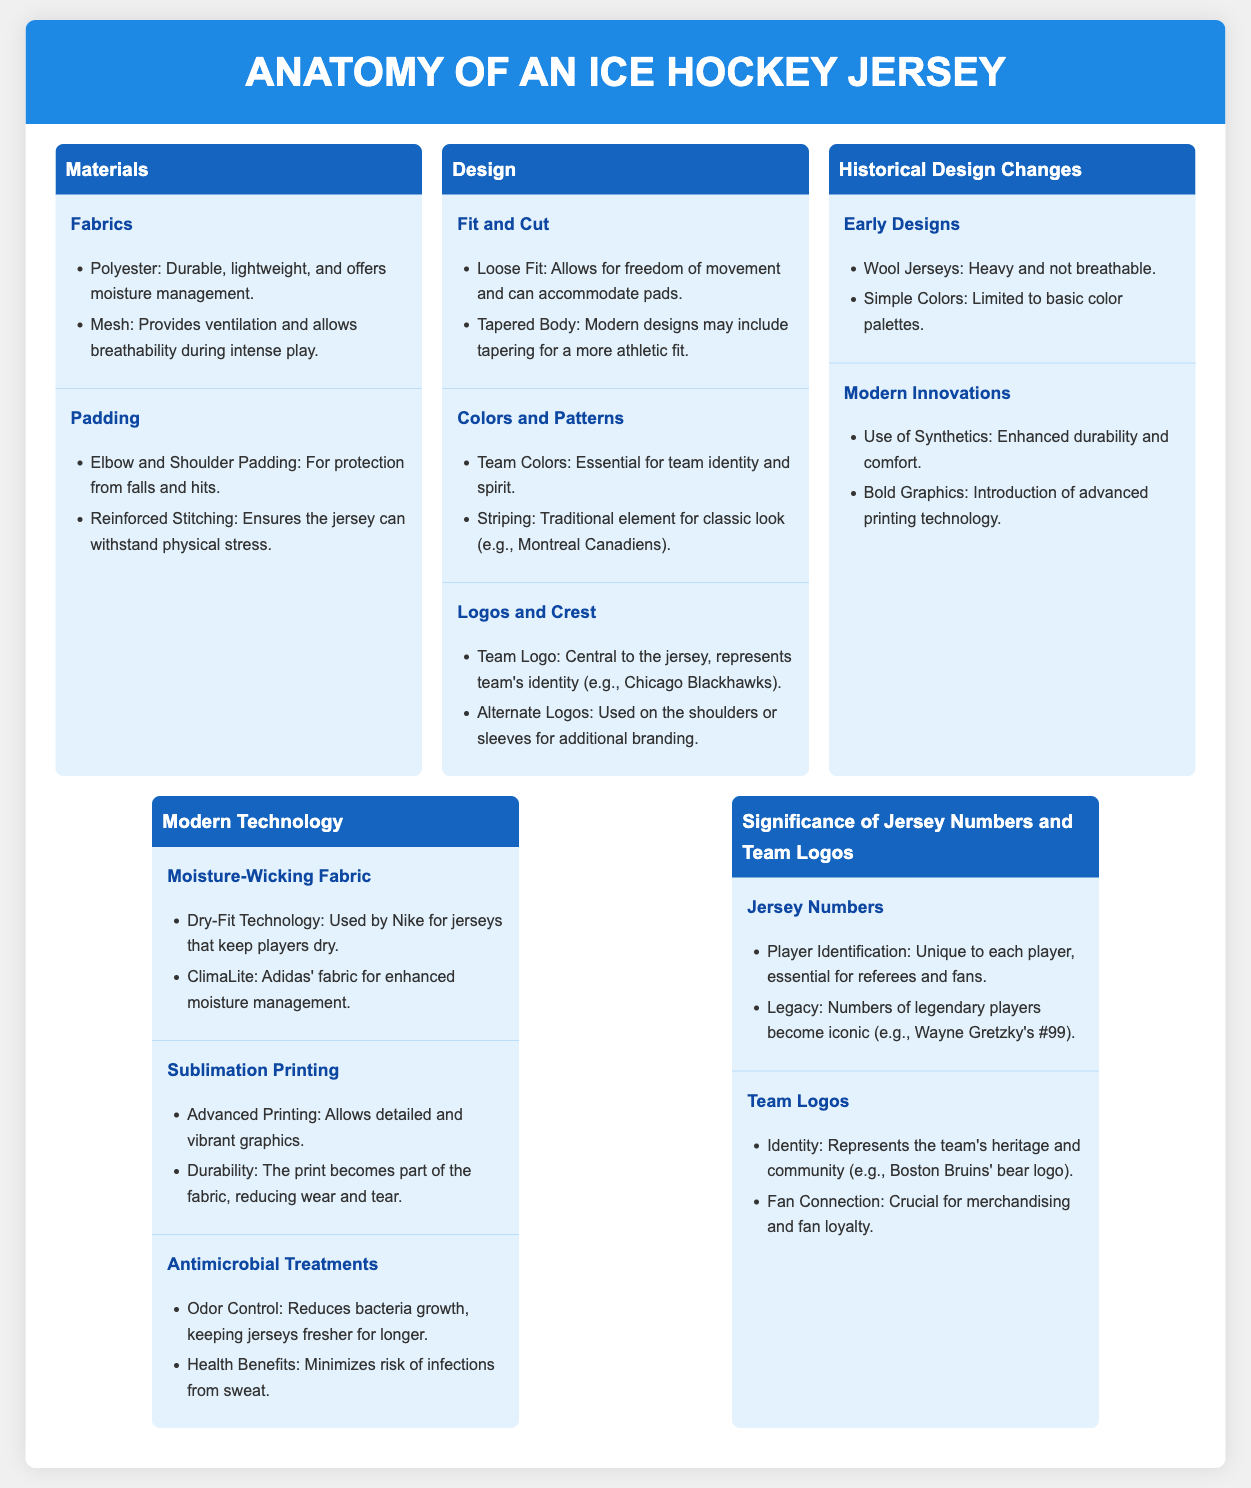what fabric is used for durability and moisture management? The fabric used for durability and moisture management is polyester.
Answer: polyester what type of padding is included in ice hockey jerseys? The padding included in ice hockey jerseys consists of elbow and shoulder padding.
Answer: elbow and shoulder padding what technological feature is used by Nike for keeping players dry? The technological feature used by Nike for keeping players dry is Dry-Fit Technology.
Answer: Dry-Fit Technology what does the team logo represent? The team logo represents the team's heritage and community.
Answer: team's heritage and community what is the significance of jersey numbers? The significance of jersey numbers is that they are unique to each player and essential for referees and fans.
Answer: unique to each player and essential for referees and fans how has the material changed from early designs to modern jerseys? The material has changed from wool jerseys, which were heavy and not breathable, to the use of synthetics for enhanced durability and comfort.
Answer: wool to synthetics what role do team colors play in jersey design? The role of team colors in jersey design is essential for team identity and spirit.
Answer: team identity and spirit what does sublimation printing provide for modern jerseys? Sublimation printing provides detailed and vibrant graphics for modern jerseys.
Answer: detailed and vibrant graphics what type of fit allows for freedom of movement in jerseys? The type of fit that allows for freedom of movement in jerseys is loose fit.
Answer: loose fit 